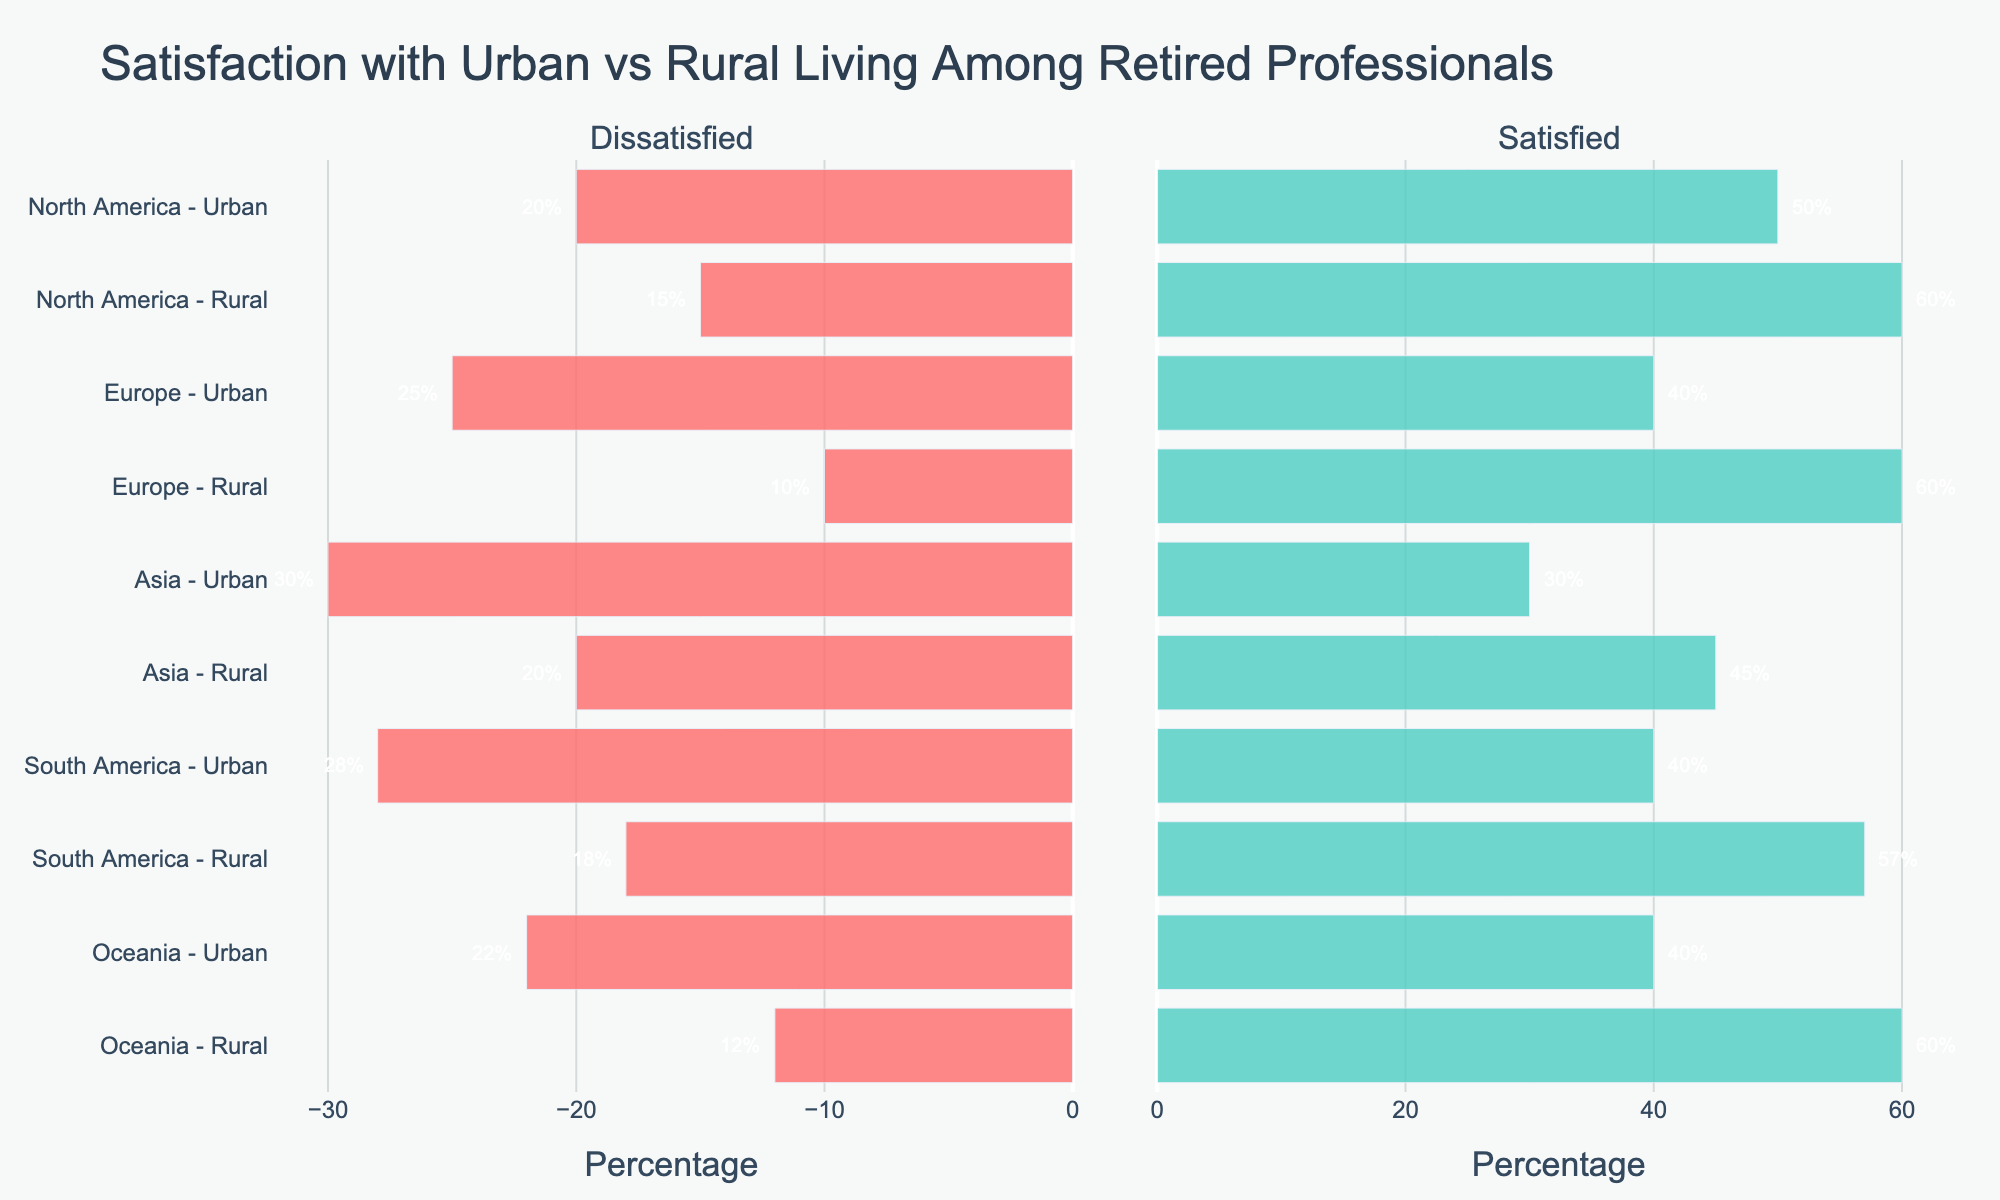How does the dissatisfaction level of Urban living in North America compare to Rural living in Europe? Urban living in North America has 20% dissatisfied, while Rural living in Europe has 10% dissatisfied. By comparing these, North America Urban living has a higher dissatisfaction level.
Answer: North America Urban has more dissatisfaction Which location type, Urban or Rural, in Oceania has the highest satisfaction level? In Oceania, the satisfaction level is 40% for Urban and 60% for Rural. Comparing these values, Rural has the higher satisfaction level.
Answer: Rural What is the total neutral response percentage in Asia? In Asia, the neutral responses are 40% for Urban and 35% for Rural. Summing these up (40% + 35%) gives a total of 75%.
Answer: 75% Between Urban living in Asia and Urban living in South America, which has a higher percentage of people satisfied, and by how much? Asia Urban has 30% satisfied, and South America Urban has 40% satisfied. The difference is 40% - 30% = 10%.
Answer: South America Urban by 10% How does the dissatisfaction level in South America Urban compare visually with that of Oceania Rural? South America Urban has a 28% dissatisfaction level and Oceania Rural has a 12% dissatisfaction level. Visually, this means South America Urban's bar is longer than that of Oceania Rural.
Answer: South America Urban has a longer bar Which location type in Europe has a higher neutral response rate, and by how much? Urban has 35% neutral and Rural has 30% neutral in Europe. The difference is 35% - 30% = 5%.
Answer: Urban by 5% What is the average satisfaction percentage for Rural living across all regions? Satisfaction percentages for Rural living are: North America: 60%, Europe: 60%, Asia: 45%, South America: 57%, Oceania: 60%. Average = (60% + 60% + 45% + 57% + 60%) / 5 = 56.4%.
Answer: 56.4% What observation can you make about the dissatisfaction level of Urban living across all regions? The dissatisfaction percentages for Urban living are: North America: 20%, Europe: 25%, Asia: 30%, South America: 28%, Oceania: 22%. All these percentages are relatively higher than their Rural counterparts, indicating Urban living tends to have more dissatisfaction across all regions.
Answer: Urban living generally has higher dissatisfaction 